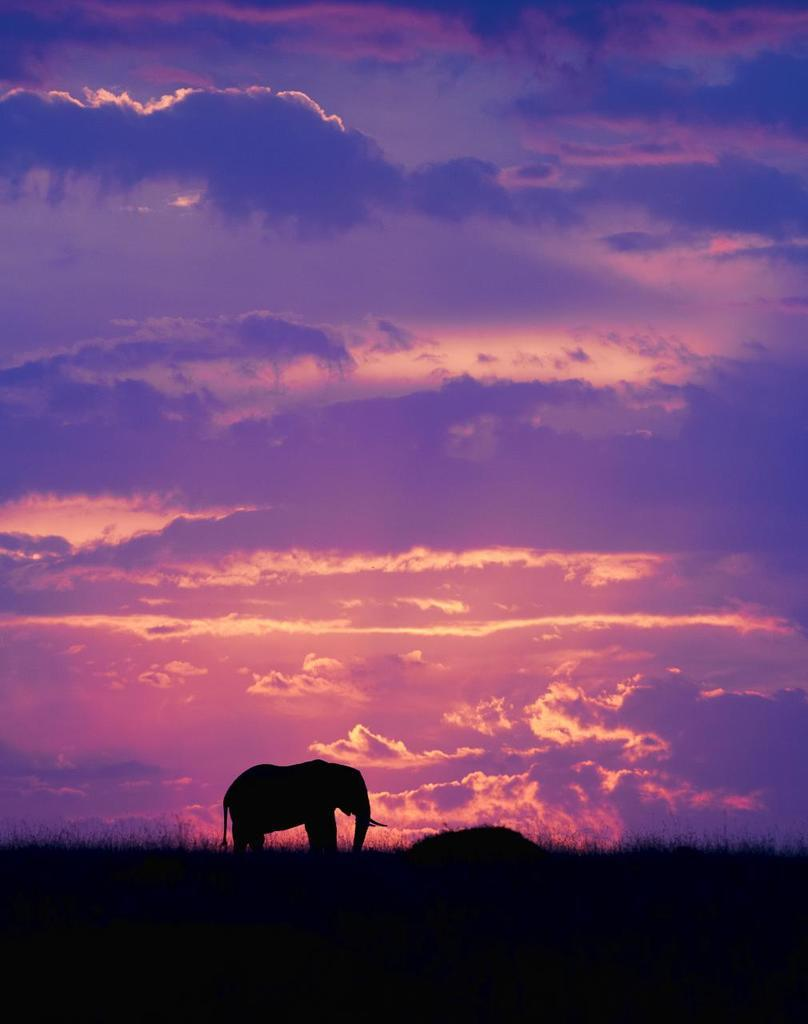What is the main subject in the center of the image? There is an elephant in the center of the image. What type of vegetation is at the bottom of the image? There is grass at the bottom of the image. What is visible at the top of the image? The sky is visible at the top of the image. What can be seen in the sky? Clouds are present in the sky. What color is the crayon that the elephant is holding in the image? There is no crayon present in the image, and the elephant is not holding anything. 